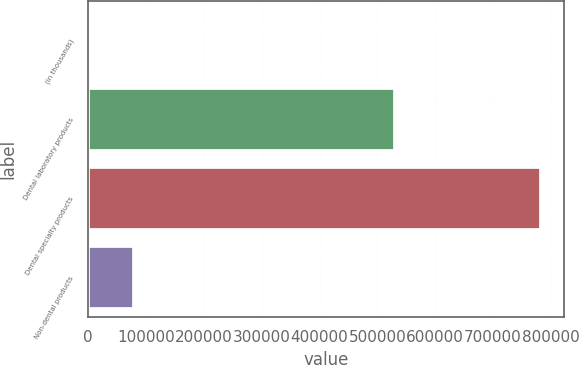Convert chart. <chart><loc_0><loc_0><loc_500><loc_500><bar_chart><fcel>(in thousands)<fcel>Dental laboratory products<fcel>Dental specialty products<fcel>Non-dental products<nl><fcel>2007<fcel>530821<fcel>782808<fcel>80087.1<nl></chart> 